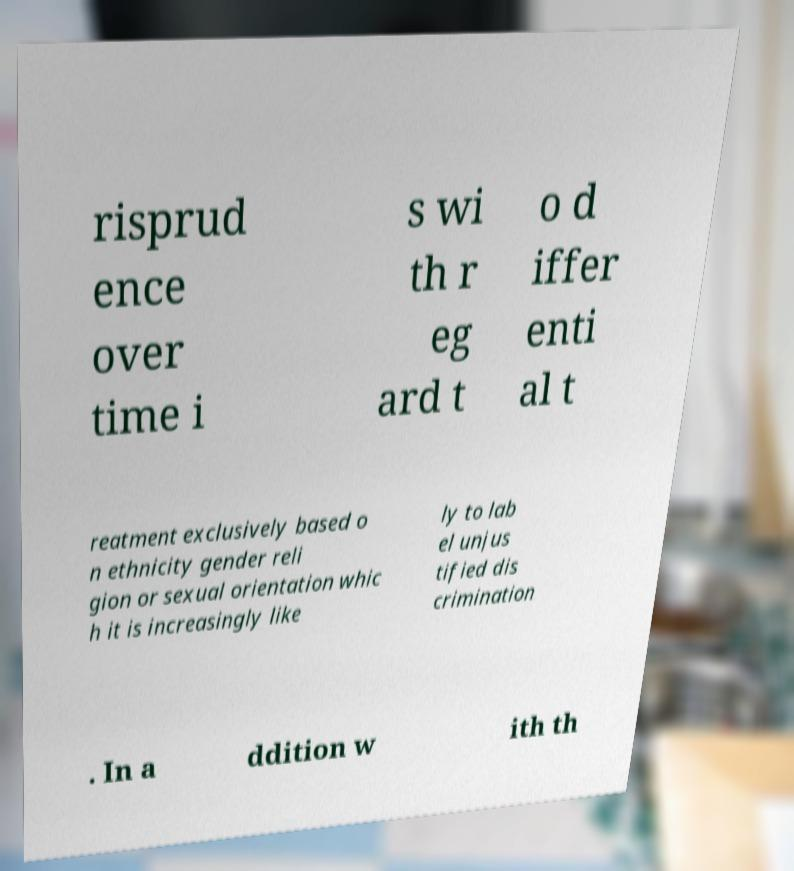Could you assist in decoding the text presented in this image and type it out clearly? risprud ence over time i s wi th r eg ard t o d iffer enti al t reatment exclusively based o n ethnicity gender reli gion or sexual orientation whic h it is increasingly like ly to lab el unjus tified dis crimination . In a ddition w ith th 